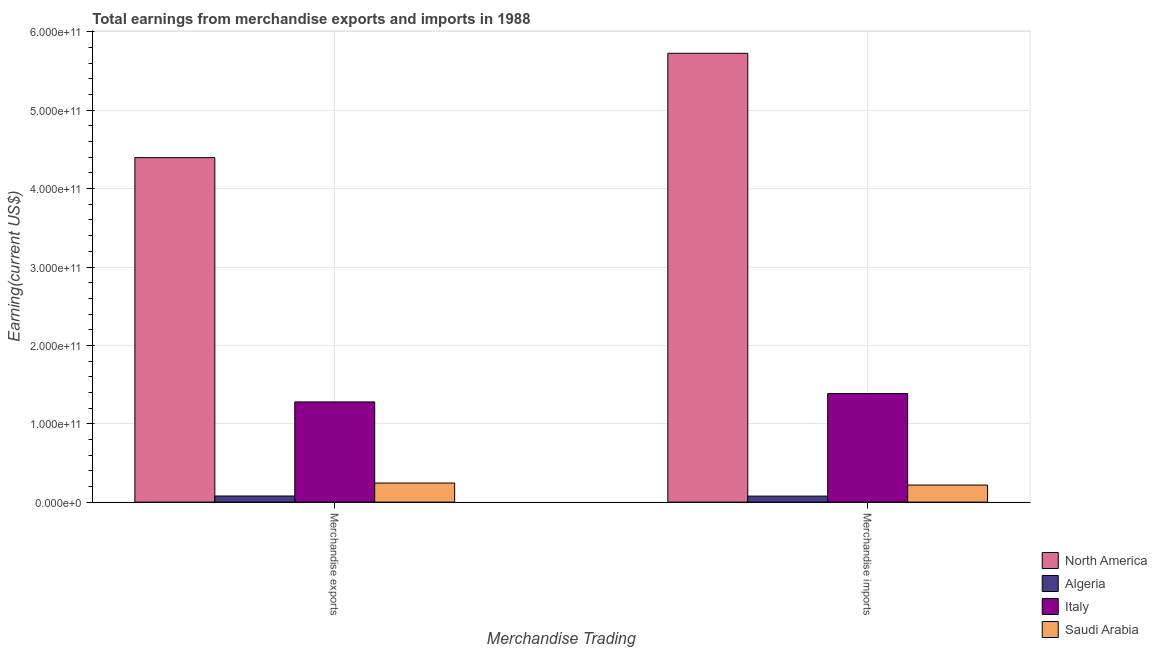Are the number of bars per tick equal to the number of legend labels?
Your answer should be very brief. Yes. What is the earnings from merchandise exports in Algeria?
Offer a very short reply. 7.81e+09. Across all countries, what is the maximum earnings from merchandise exports?
Ensure brevity in your answer.  4.40e+11. Across all countries, what is the minimum earnings from merchandise imports?
Ensure brevity in your answer.  7.69e+09. In which country was the earnings from merchandise exports minimum?
Offer a terse response. Algeria. What is the total earnings from merchandise exports in the graph?
Offer a very short reply. 6.00e+11. What is the difference between the earnings from merchandise exports in Italy and that in Algeria?
Give a very brief answer. 1.20e+11. What is the difference between the earnings from merchandise exports in Saudi Arabia and the earnings from merchandise imports in North America?
Your answer should be very brief. -5.48e+11. What is the average earnings from merchandise imports per country?
Provide a short and direct response. 1.85e+11. What is the difference between the earnings from merchandise imports and earnings from merchandise exports in Algeria?
Your answer should be compact. -1.20e+08. In how many countries, is the earnings from merchandise imports greater than 80000000000 US$?
Give a very brief answer. 2. What is the ratio of the earnings from merchandise imports in Saudi Arabia to that in North America?
Your answer should be compact. 0.04. Is the earnings from merchandise imports in Algeria less than that in North America?
Make the answer very short. Yes. What does the 1st bar from the left in Merchandise imports represents?
Give a very brief answer. North America. What does the 2nd bar from the right in Merchandise imports represents?
Offer a very short reply. Italy. How many countries are there in the graph?
Provide a short and direct response. 4. What is the difference between two consecutive major ticks on the Y-axis?
Offer a terse response. 1.00e+11. How are the legend labels stacked?
Provide a short and direct response. Vertical. What is the title of the graph?
Provide a succinct answer. Total earnings from merchandise exports and imports in 1988. What is the label or title of the X-axis?
Your answer should be very brief. Merchandise Trading. What is the label or title of the Y-axis?
Your response must be concise. Earning(current US$). What is the Earning(current US$) of North America in Merchandise exports?
Give a very brief answer. 4.40e+11. What is the Earning(current US$) in Algeria in Merchandise exports?
Offer a very short reply. 7.81e+09. What is the Earning(current US$) of Italy in Merchandise exports?
Provide a short and direct response. 1.28e+11. What is the Earning(current US$) of Saudi Arabia in Merchandise exports?
Offer a terse response. 2.44e+1. What is the Earning(current US$) in North America in Merchandise imports?
Offer a terse response. 5.73e+11. What is the Earning(current US$) of Algeria in Merchandise imports?
Your answer should be compact. 7.69e+09. What is the Earning(current US$) of Italy in Merchandise imports?
Offer a terse response. 1.39e+11. What is the Earning(current US$) in Saudi Arabia in Merchandise imports?
Your answer should be very brief. 2.18e+1. Across all Merchandise Trading, what is the maximum Earning(current US$) in North America?
Your answer should be very brief. 5.73e+11. Across all Merchandise Trading, what is the maximum Earning(current US$) of Algeria?
Your response must be concise. 7.81e+09. Across all Merchandise Trading, what is the maximum Earning(current US$) of Italy?
Your answer should be compact. 1.39e+11. Across all Merchandise Trading, what is the maximum Earning(current US$) in Saudi Arabia?
Offer a very short reply. 2.44e+1. Across all Merchandise Trading, what is the minimum Earning(current US$) of North America?
Your answer should be very brief. 4.40e+11. Across all Merchandise Trading, what is the minimum Earning(current US$) in Algeria?
Your answer should be very brief. 7.69e+09. Across all Merchandise Trading, what is the minimum Earning(current US$) of Italy?
Offer a terse response. 1.28e+11. Across all Merchandise Trading, what is the minimum Earning(current US$) in Saudi Arabia?
Keep it short and to the point. 2.18e+1. What is the total Earning(current US$) in North America in the graph?
Your response must be concise. 1.01e+12. What is the total Earning(current US$) in Algeria in the graph?
Provide a succinct answer. 1.55e+1. What is the total Earning(current US$) in Italy in the graph?
Provide a succinct answer. 2.66e+11. What is the total Earning(current US$) of Saudi Arabia in the graph?
Provide a succinct answer. 4.62e+1. What is the difference between the Earning(current US$) in North America in Merchandise exports and that in Merchandise imports?
Offer a very short reply. -1.33e+11. What is the difference between the Earning(current US$) of Algeria in Merchandise exports and that in Merchandise imports?
Provide a short and direct response. 1.20e+08. What is the difference between the Earning(current US$) of Italy in Merchandise exports and that in Merchandise imports?
Provide a short and direct response. -1.07e+1. What is the difference between the Earning(current US$) of Saudi Arabia in Merchandise exports and that in Merchandise imports?
Provide a short and direct response. 2.59e+09. What is the difference between the Earning(current US$) in North America in Merchandise exports and the Earning(current US$) in Algeria in Merchandise imports?
Make the answer very short. 4.32e+11. What is the difference between the Earning(current US$) in North America in Merchandise exports and the Earning(current US$) in Italy in Merchandise imports?
Ensure brevity in your answer.  3.01e+11. What is the difference between the Earning(current US$) in North America in Merchandise exports and the Earning(current US$) in Saudi Arabia in Merchandise imports?
Ensure brevity in your answer.  4.18e+11. What is the difference between the Earning(current US$) of Algeria in Merchandise exports and the Earning(current US$) of Italy in Merchandise imports?
Ensure brevity in your answer.  -1.31e+11. What is the difference between the Earning(current US$) in Algeria in Merchandise exports and the Earning(current US$) in Saudi Arabia in Merchandise imports?
Your answer should be compact. -1.40e+1. What is the difference between the Earning(current US$) in Italy in Merchandise exports and the Earning(current US$) in Saudi Arabia in Merchandise imports?
Ensure brevity in your answer.  1.06e+11. What is the average Earning(current US$) in North America per Merchandise Trading?
Keep it short and to the point. 5.06e+11. What is the average Earning(current US$) of Algeria per Merchandise Trading?
Your answer should be very brief. 7.75e+09. What is the average Earning(current US$) of Italy per Merchandise Trading?
Provide a succinct answer. 1.33e+11. What is the average Earning(current US$) of Saudi Arabia per Merchandise Trading?
Ensure brevity in your answer.  2.31e+1. What is the difference between the Earning(current US$) of North America and Earning(current US$) of Algeria in Merchandise exports?
Your answer should be compact. 4.32e+11. What is the difference between the Earning(current US$) in North America and Earning(current US$) in Italy in Merchandise exports?
Give a very brief answer. 3.12e+11. What is the difference between the Earning(current US$) of North America and Earning(current US$) of Saudi Arabia in Merchandise exports?
Offer a very short reply. 4.15e+11. What is the difference between the Earning(current US$) of Algeria and Earning(current US$) of Italy in Merchandise exports?
Keep it short and to the point. -1.20e+11. What is the difference between the Earning(current US$) in Algeria and Earning(current US$) in Saudi Arabia in Merchandise exports?
Your answer should be compact. -1.66e+1. What is the difference between the Earning(current US$) of Italy and Earning(current US$) of Saudi Arabia in Merchandise exports?
Provide a succinct answer. 1.03e+11. What is the difference between the Earning(current US$) of North America and Earning(current US$) of Algeria in Merchandise imports?
Ensure brevity in your answer.  5.65e+11. What is the difference between the Earning(current US$) in North America and Earning(current US$) in Italy in Merchandise imports?
Ensure brevity in your answer.  4.34e+11. What is the difference between the Earning(current US$) in North America and Earning(current US$) in Saudi Arabia in Merchandise imports?
Give a very brief answer. 5.51e+11. What is the difference between the Earning(current US$) of Algeria and Earning(current US$) of Italy in Merchandise imports?
Your response must be concise. -1.31e+11. What is the difference between the Earning(current US$) of Algeria and Earning(current US$) of Saudi Arabia in Merchandise imports?
Provide a short and direct response. -1.41e+1. What is the difference between the Earning(current US$) in Italy and Earning(current US$) in Saudi Arabia in Merchandise imports?
Provide a succinct answer. 1.17e+11. What is the ratio of the Earning(current US$) in North America in Merchandise exports to that in Merchandise imports?
Give a very brief answer. 0.77. What is the ratio of the Earning(current US$) in Algeria in Merchandise exports to that in Merchandise imports?
Offer a terse response. 1.02. What is the ratio of the Earning(current US$) in Italy in Merchandise exports to that in Merchandise imports?
Your answer should be compact. 0.92. What is the ratio of the Earning(current US$) in Saudi Arabia in Merchandise exports to that in Merchandise imports?
Provide a short and direct response. 1.12. What is the difference between the highest and the second highest Earning(current US$) in North America?
Your answer should be very brief. 1.33e+11. What is the difference between the highest and the second highest Earning(current US$) in Algeria?
Make the answer very short. 1.20e+08. What is the difference between the highest and the second highest Earning(current US$) of Italy?
Your answer should be compact. 1.07e+1. What is the difference between the highest and the second highest Earning(current US$) in Saudi Arabia?
Your answer should be compact. 2.59e+09. What is the difference between the highest and the lowest Earning(current US$) of North America?
Give a very brief answer. 1.33e+11. What is the difference between the highest and the lowest Earning(current US$) of Algeria?
Your answer should be compact. 1.20e+08. What is the difference between the highest and the lowest Earning(current US$) in Italy?
Keep it short and to the point. 1.07e+1. What is the difference between the highest and the lowest Earning(current US$) of Saudi Arabia?
Provide a short and direct response. 2.59e+09. 